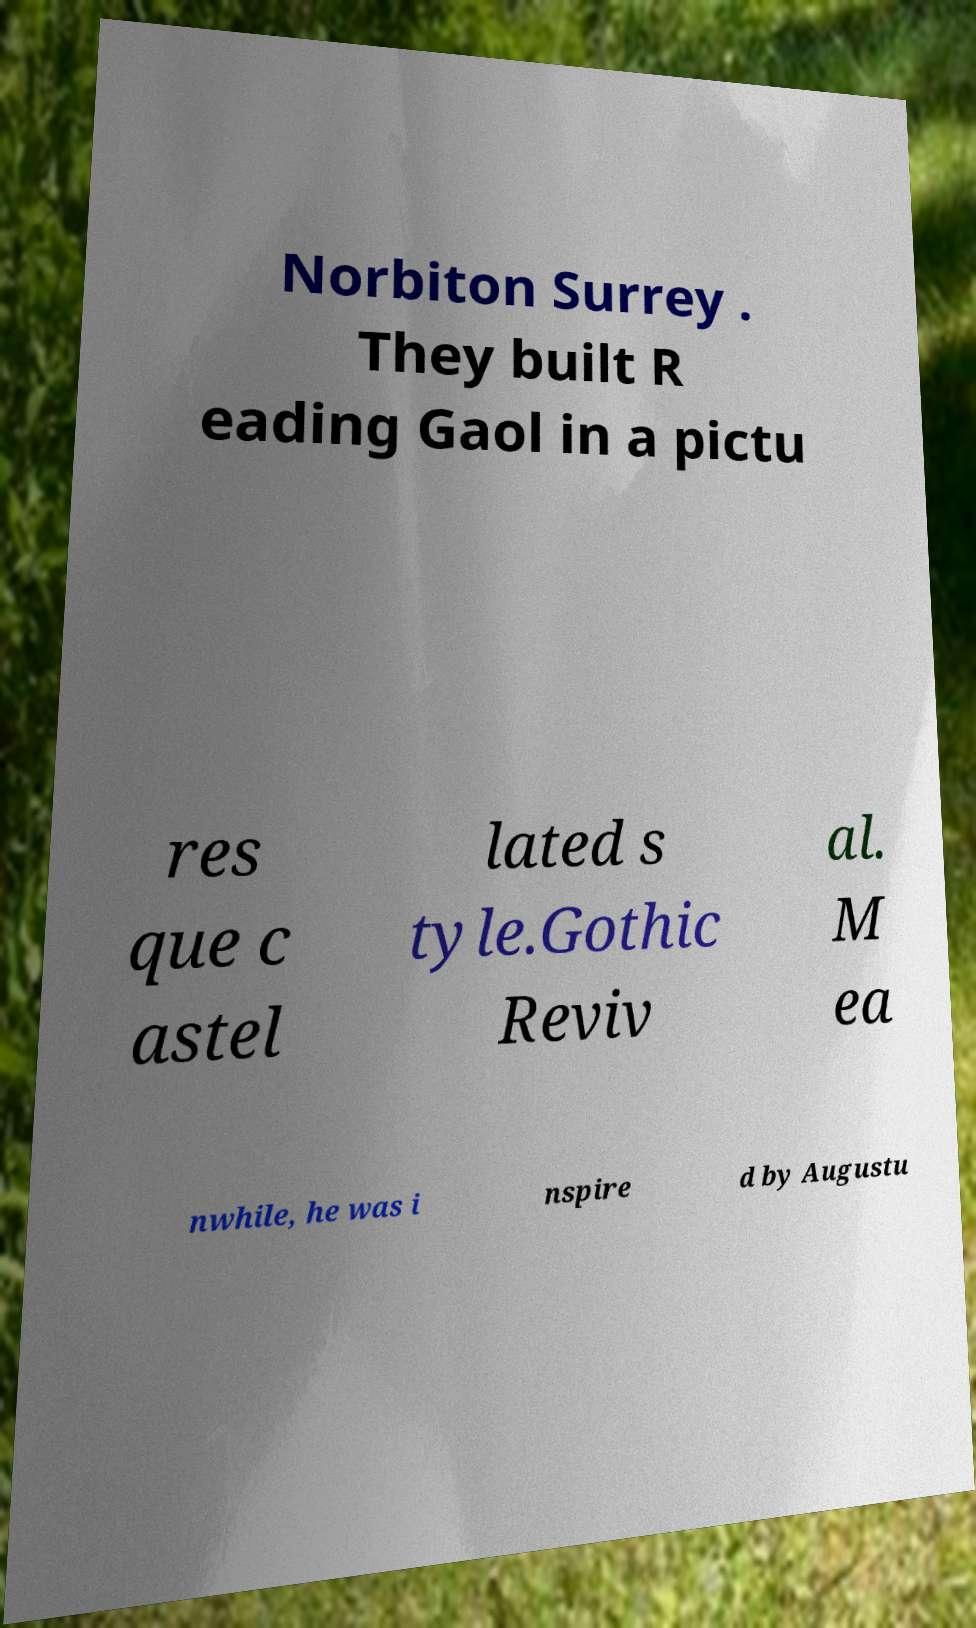Please read and relay the text visible in this image. What does it say? Norbiton Surrey . They built R eading Gaol in a pictu res que c astel lated s tyle.Gothic Reviv al. M ea nwhile, he was i nspire d by Augustu 